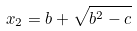Convert formula to latex. <formula><loc_0><loc_0><loc_500><loc_500>x _ { 2 } = b + \sqrt { b ^ { 2 } - c }</formula> 